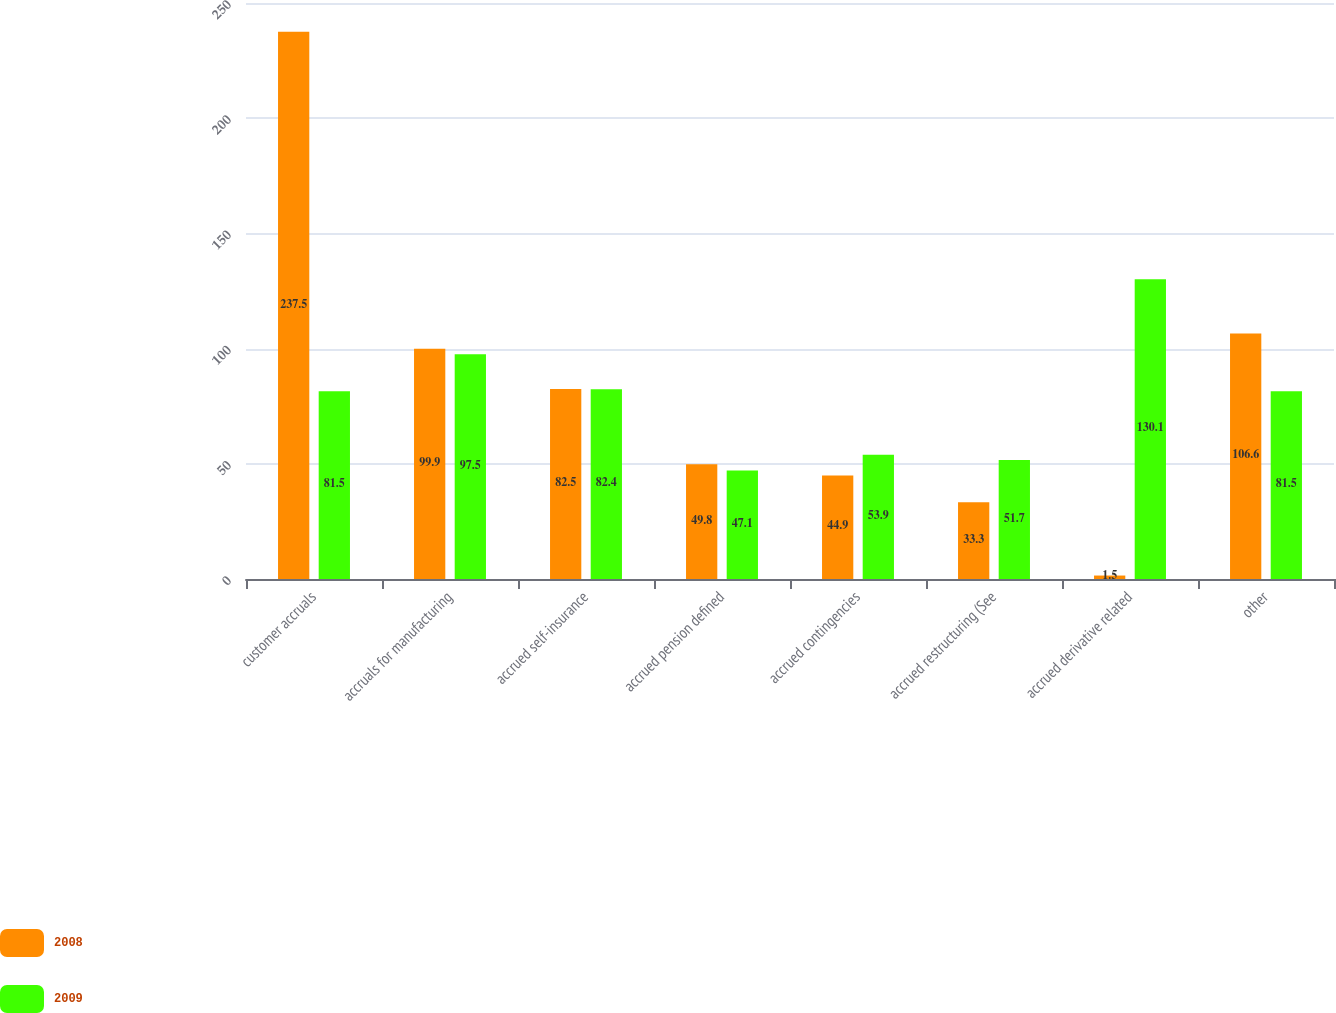Convert chart. <chart><loc_0><loc_0><loc_500><loc_500><stacked_bar_chart><ecel><fcel>customer accruals<fcel>accruals for manufacturing<fcel>accrued self-insurance<fcel>accrued pension defined<fcel>accrued contingencies<fcel>accrued restructuring (See<fcel>accrued derivative related<fcel>other<nl><fcel>2008<fcel>237.5<fcel>99.9<fcel>82.5<fcel>49.8<fcel>44.9<fcel>33.3<fcel>1.5<fcel>106.6<nl><fcel>2009<fcel>81.5<fcel>97.5<fcel>82.4<fcel>47.1<fcel>53.9<fcel>51.7<fcel>130.1<fcel>81.5<nl></chart> 